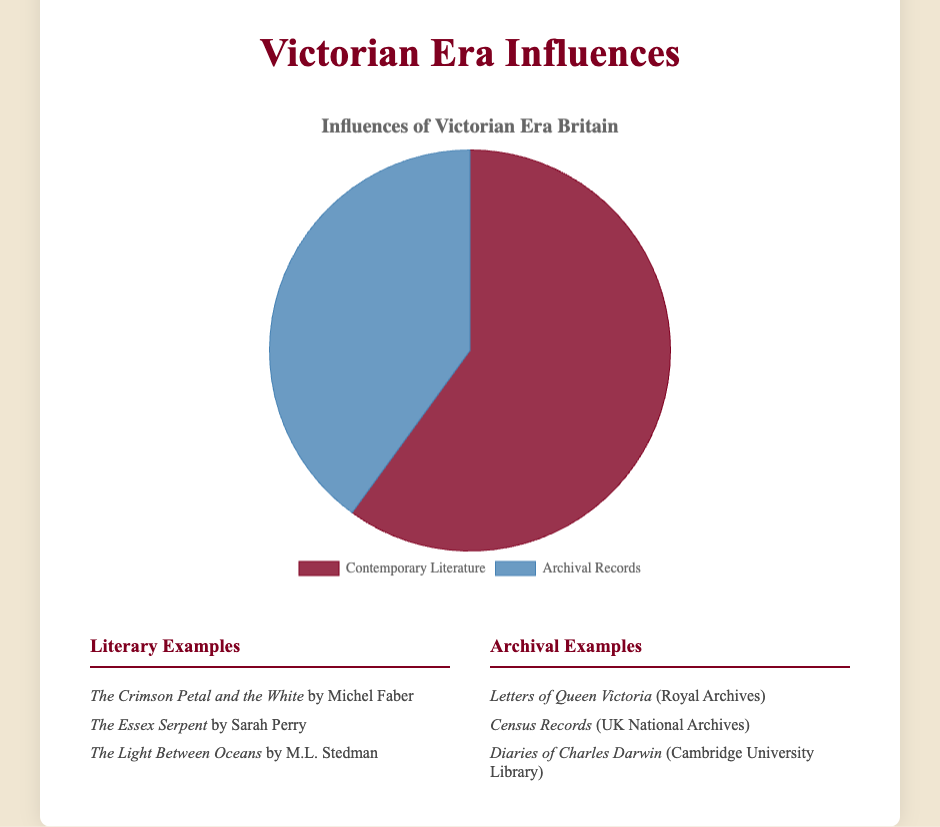Which category has a higher influence, Contemporary Literature or Archival Records? To determine the category with the higher influence, compare the values of both categories given in the chart. The influence on Contemporary Literature is 60%, while the influence on Archival Records is 40%.
Answer: Contemporary Literature What is the difference in influence between Contemporary Literature and Archival Records? To find the difference in influence, subtract the value for Archival Records from the value for Contemporary Literature: 60% - 40% = 20%.
Answer: 20% What percent of the total influence comes from Archival Records? The total influence is 100%. The value given for Archival Records is 40%. Thus, 40% of the total influence comes from Archival Records.
Answer: 40% If the influences were divided equally, what value would each category have? If the influences were divided equally, each category would have half of the total value. The total value is 100%, so each category would have 100% / 2 = 50%.
Answer: 50% What is the combined influence of both categories? Add the values of both categories to get the total combined influence: 60% (Literature) + 40% (Records) = 100%.
Answer: 100% In terms of visual representation, what color represents Contemporary Literature? Examine the pie chart, where the portion representing Contemporary Literature is shown. The color corresponding to Contemporary Literature is a dark red color.
Answer: Dark red In terms of visual representation, what color represents Archival Records? Examine the pie chart, where the portion representing Archival Records is shown. The color corresponding to Archival Records is a shade of blue.
Answer: Blue Which category has a visually larger section in the pie chart? The visually larger section is represented by the category with a higher percentage. Since Contemporary Literature has 60%, which is greater than the 40% for Archival Records, it occupies a larger section of the pie chart.
Answer: Contemporary Literature If the influence on Contemporary Literature were to increase by 10%, what would the new value be and how would it impact the relative proportions? Increasing Contemporary Literature's influence by 10% adds 60% + 10% = 70%. This would decrease the remaining total influence available for Archival Records to 100% - 70% = 30%.
Answer: Contemporary Literature: 70%, Archival Records: 30% 